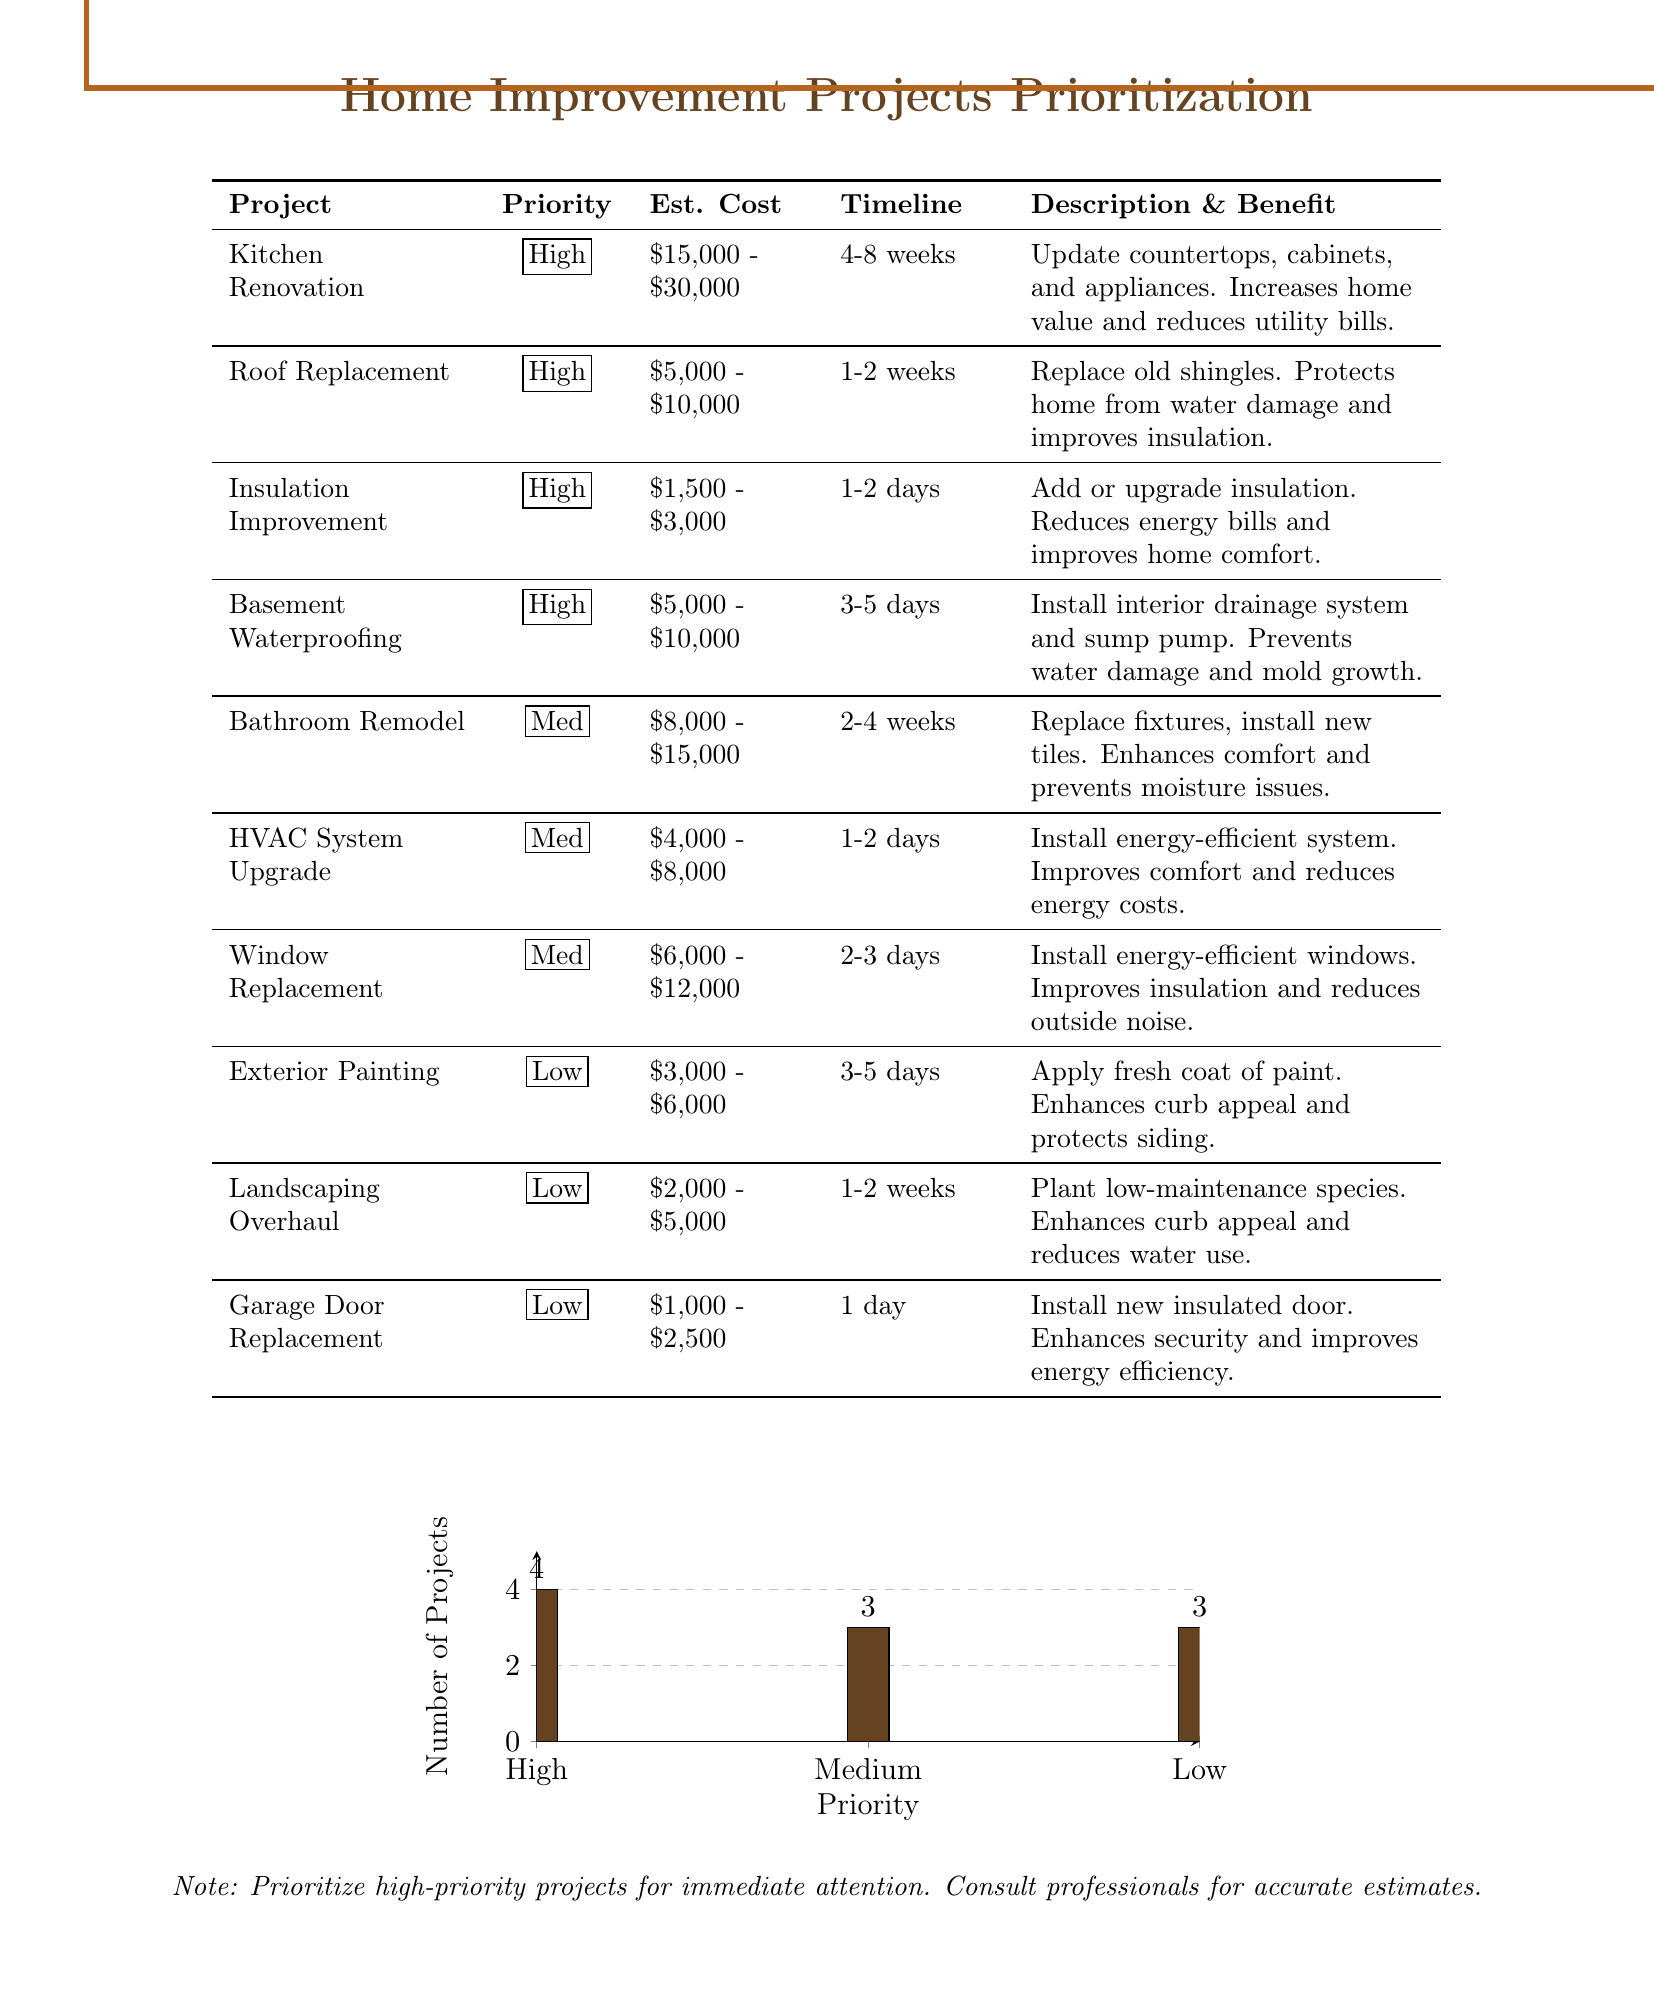What is the estimated cost of Kitchen Renovation? The estimated cost is listed under the Kitchen Renovation project in the document.
Answer: $15,000 - $30,000 How long is the timeline for Bathroom Remodel? The timeline for Bathroom Remodel can be found in the project details section.
Answer: 2-4 weeks What is the priority level of Roof Replacement? The priority level is indicated for each project, including Roof Replacement.
Answer: High Which project has the lowest estimated cost? This information requires comparing the estimated costs of all projects to identify the lowest one.
Answer: Garage Door Replacement How many high-priority projects are there? The count of high-priority projects can be determined by counting the corresponding entries in the document.
Answer: 4 What benefit does Insulation Improvement provide? The benefit is specified in the description and benefit section of the Insulation Improvement project.
Answer: Reduces energy bills and improves home comfort What is the total estimated cost range for Exterior Painting? The estimated cost range is provided in the project details section for Exterior Painting.
Answer: $3,000 - $6,000 What is the main purpose of Basement Waterproofing? This purpose is outlined in the description and benefit section associated with the Basement Waterproofing project.
Answer: Prevents water damage and mold growth How many projects are categorized as Low priority? The document presents projects categorized by priority, allowing for a count of low-priority entries.
Answer: 3 